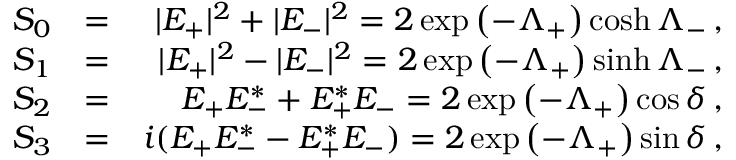Convert formula to latex. <formula><loc_0><loc_0><loc_500><loc_500>\begin{array} { r l r } { S _ { 0 } } & { = } & { | E _ { + } | ^ { 2 } + | E _ { - } | ^ { 2 } = 2 \exp \left ( - \Lambda _ { + } \right ) \cosh \Lambda _ { - } \, , } \\ { S _ { 1 } } & { = } & { | E _ { + } | ^ { 2 } - | E _ { - } | ^ { 2 } = 2 \exp \left ( - \Lambda _ { + } \right ) \sinh \Lambda _ { - } \, , } \\ { S _ { 2 } } & { = } & { E _ { + } E _ { - } ^ { * } + E _ { + } ^ { * } E _ { - } = 2 \exp \left ( - \Lambda _ { + } \right ) \cos \delta \, , } \\ { S _ { 3 } } & { = } & { i ( E _ { + } E _ { - } ^ { * } - E _ { + } ^ { * } E _ { - } ) = 2 \exp \left ( - \Lambda _ { + } \right ) \sin \delta \, , } \end{array}</formula> 